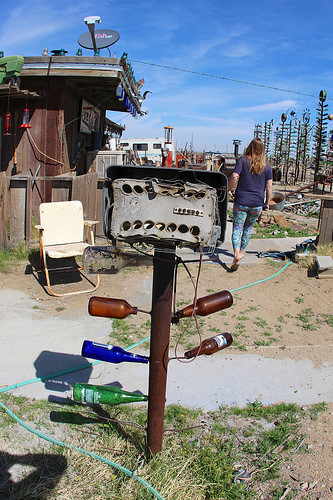<image>
Is the refrigerator next to the elephant? No. The refrigerator is not positioned next to the elephant. They are located in different areas of the scene. Where is the woman in relation to the bottle? Is it in front of the bottle? Yes. The woman is positioned in front of the bottle, appearing closer to the camera viewpoint. 